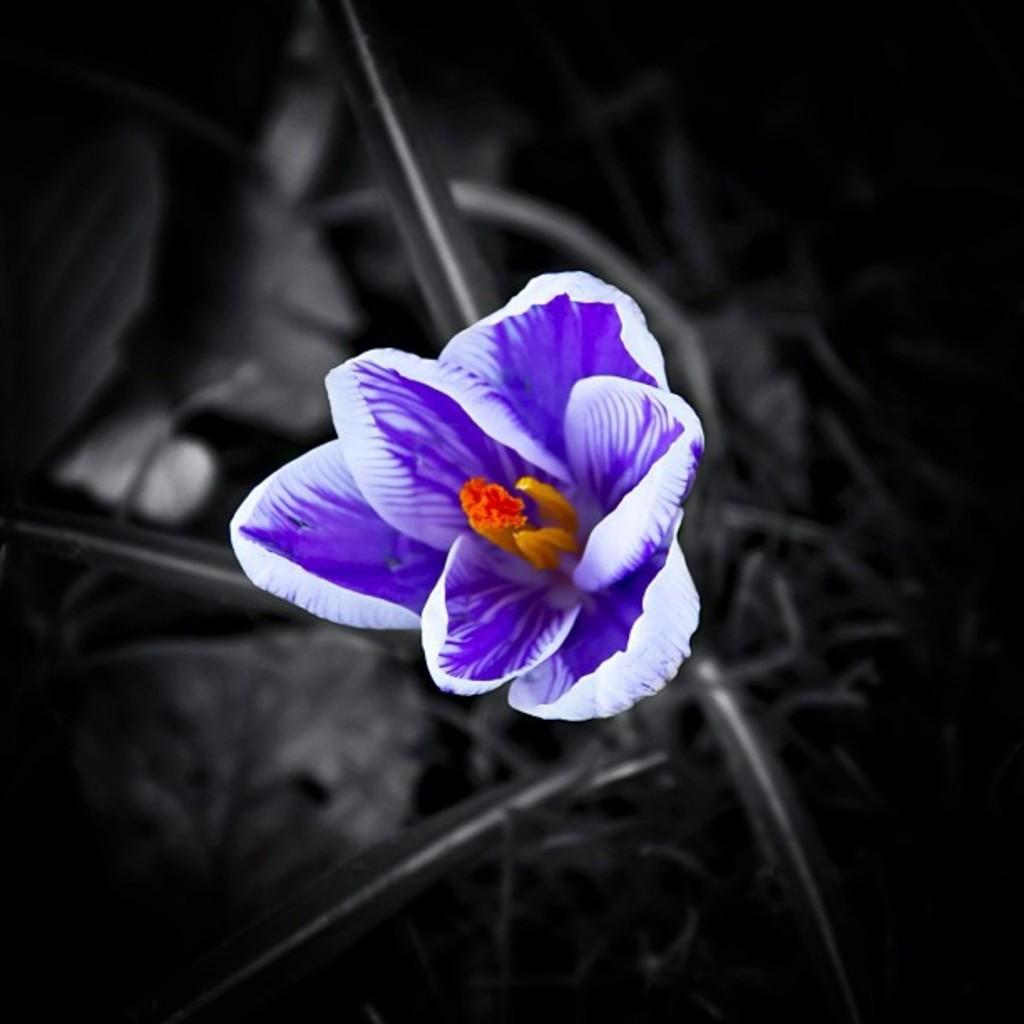What is the main subject in the front of the image? There is a flower in the front of the image. Can you describe the background of the image? The background of the image is blurry. How many bananas are hanging from the flower in the image? There are no bananas present in the image; it features a flower. What type of design is visible on the petals of the flower? The provided facts do not mention any specific design on the petals of the flower. 